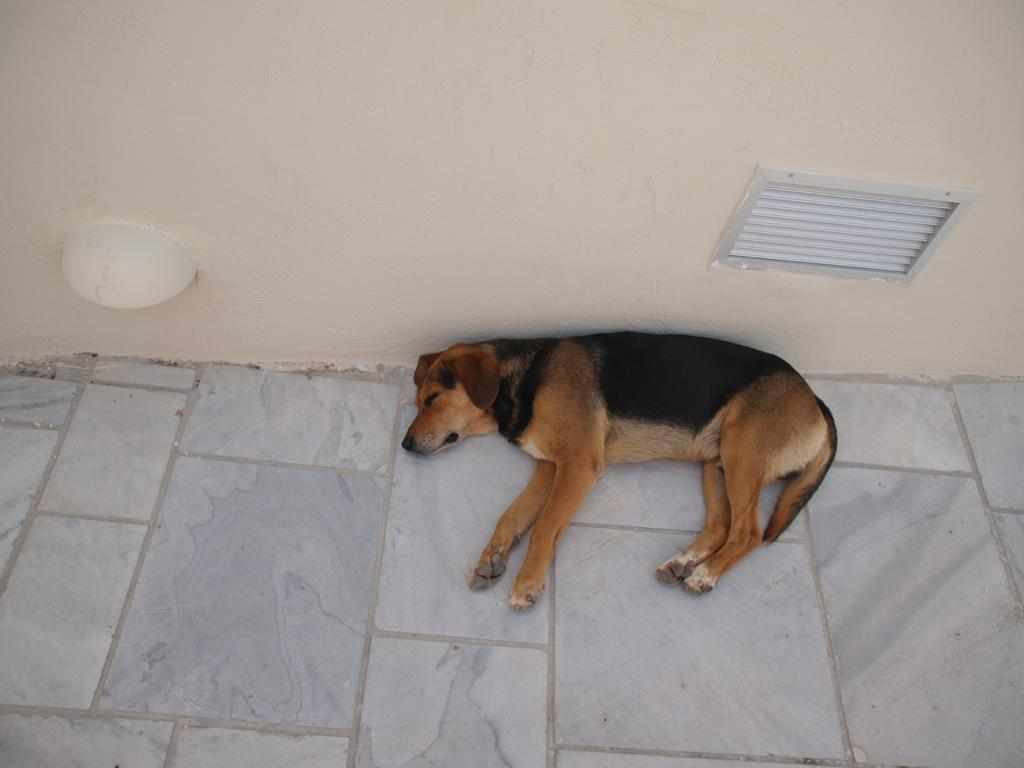What type of animal can be seen in the image? There is a dog in the image. What is the dog doing in the image? The dog is sleeping on the floor. Where is the dog located in relation to the wall? The dog is near a wall. What can be seen on the wall in the image? There is an object on the wall and a window blind. What type of key is hanging from the dog's collar in the image? There is no key present in the image; the dog is not wearing a collar. 